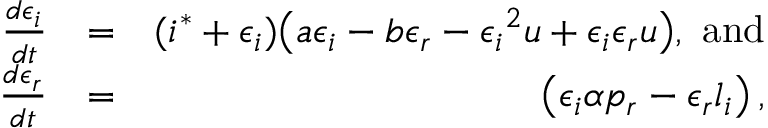Convert formula to latex. <formula><loc_0><loc_0><loc_500><loc_500>\begin{array} { r l r } { \frac { d \epsilon _ { i } } { d t } } & { = } & { ( i ^ { * } + \epsilon _ { i } ) \left ( a \epsilon _ { i } - b \epsilon _ { r } - { \epsilon _ { i } } ^ { 2 } u + \epsilon _ { i } \epsilon _ { r } u \right ) , a n d } \\ { \frac { d \epsilon _ { r } } { d t } } & { = } & { \left ( \epsilon _ { i } \alpha p _ { r } - \epsilon _ { r } l _ { i } \right ) , } \end{array}</formula> 